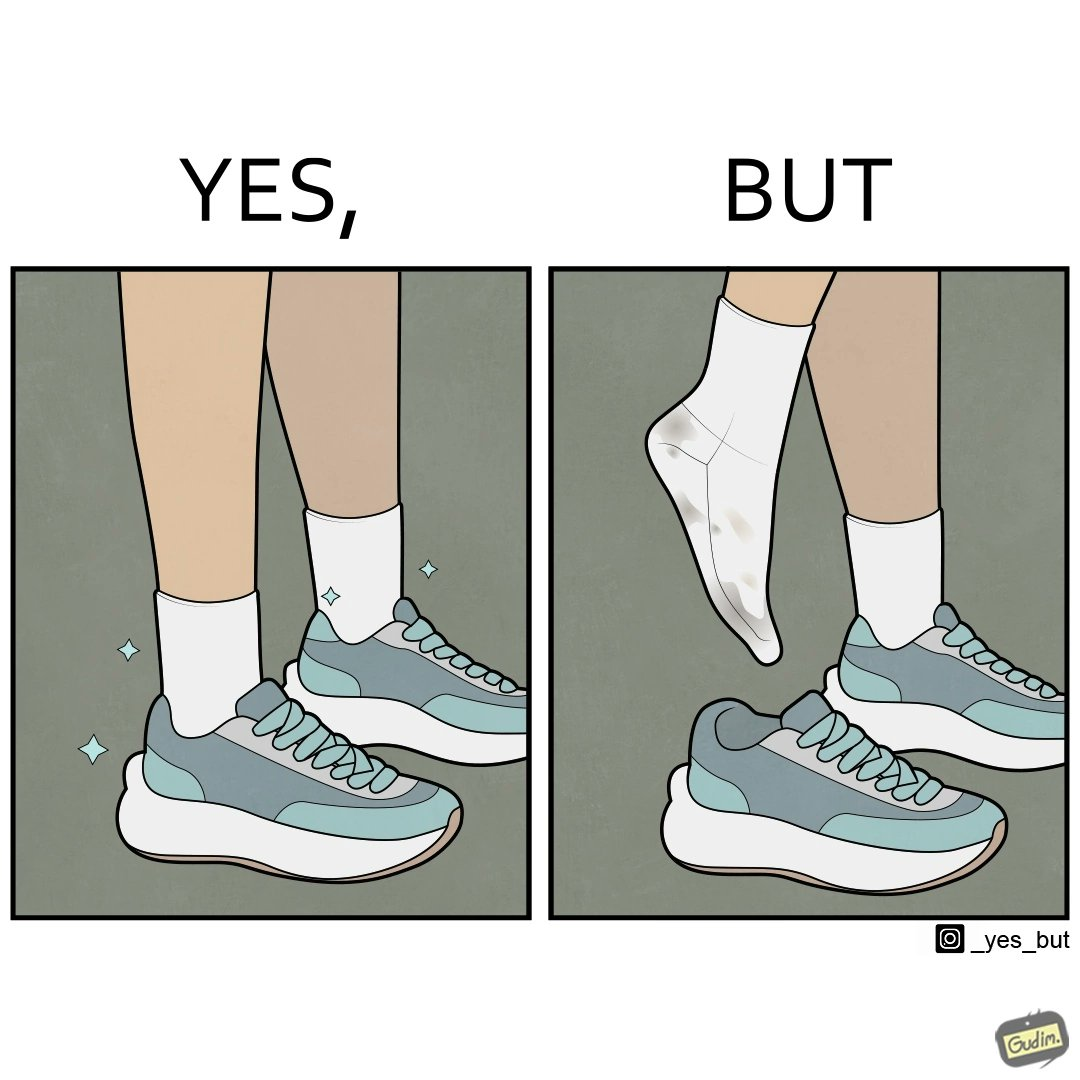Describe the contrast between the left and right parts of this image. In the left part of the image: The image is showing neat and clean shoes. In the right part of the image: The image is showing dirty shocks. 